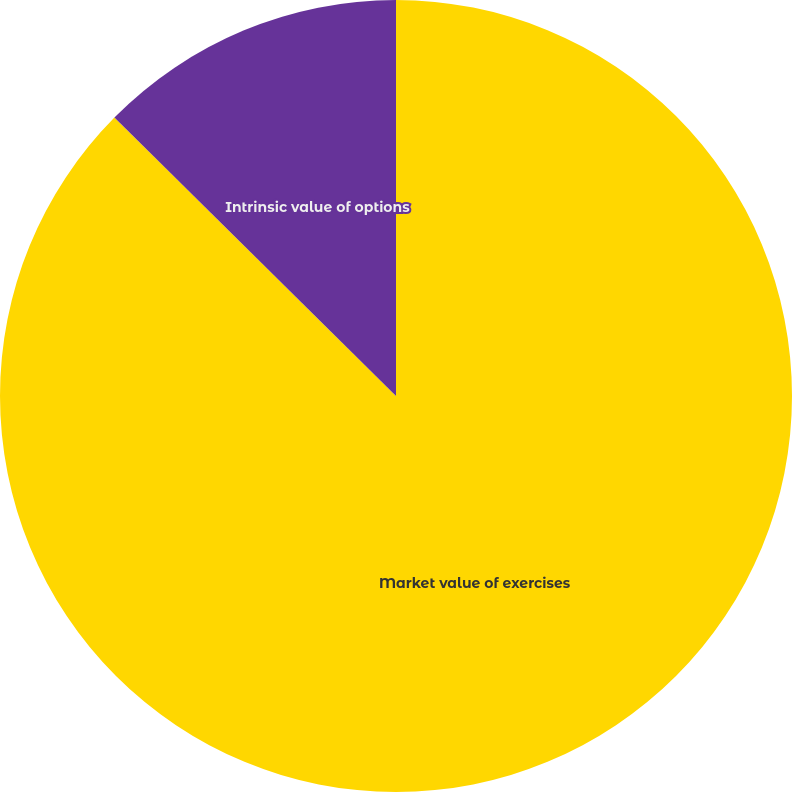Convert chart. <chart><loc_0><loc_0><loc_500><loc_500><pie_chart><fcel>Market value of exercises<fcel>Intrinsic value of options<nl><fcel>87.41%<fcel>12.59%<nl></chart> 